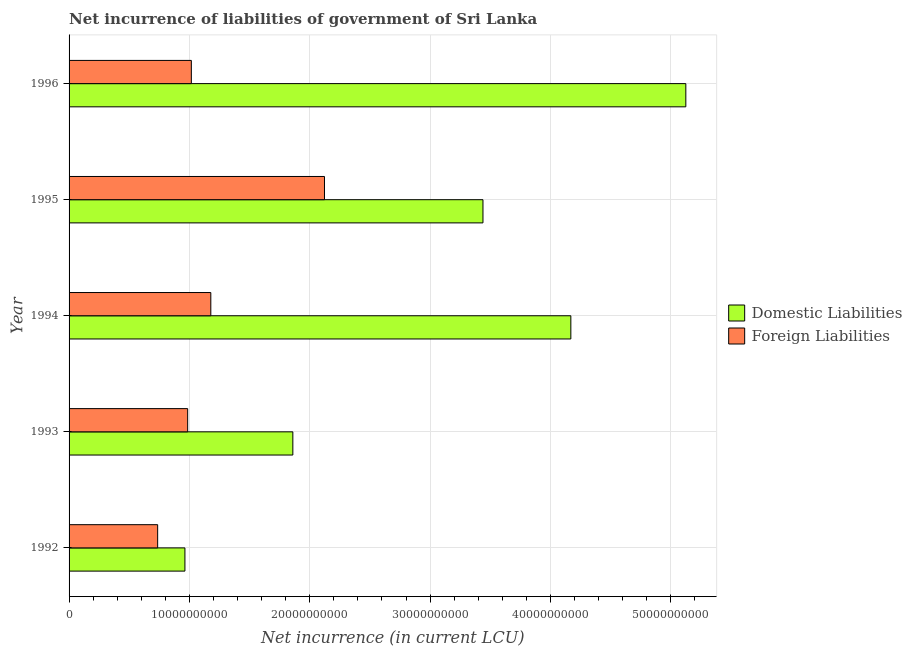Are the number of bars on each tick of the Y-axis equal?
Provide a short and direct response. Yes. How many bars are there on the 2nd tick from the top?
Make the answer very short. 2. How many bars are there on the 3rd tick from the bottom?
Provide a short and direct response. 2. What is the net incurrence of domestic liabilities in 1992?
Keep it short and to the point. 9.63e+09. Across all years, what is the maximum net incurrence of foreign liabilities?
Ensure brevity in your answer.  2.12e+1. Across all years, what is the minimum net incurrence of foreign liabilities?
Your answer should be very brief. 7.36e+09. In which year was the net incurrence of domestic liabilities minimum?
Make the answer very short. 1992. What is the total net incurrence of domestic liabilities in the graph?
Give a very brief answer. 1.56e+11. What is the difference between the net incurrence of foreign liabilities in 1995 and that in 1996?
Offer a terse response. 1.11e+1. What is the difference between the net incurrence of foreign liabilities in 1992 and the net incurrence of domestic liabilities in 1993?
Your answer should be very brief. -1.12e+1. What is the average net incurrence of domestic liabilities per year?
Provide a succinct answer. 3.11e+1. In the year 1996, what is the difference between the net incurrence of domestic liabilities and net incurrence of foreign liabilities?
Keep it short and to the point. 4.11e+1. What is the ratio of the net incurrence of domestic liabilities in 1992 to that in 1993?
Ensure brevity in your answer.  0.52. What is the difference between the highest and the second highest net incurrence of domestic liabilities?
Offer a terse response. 9.56e+09. What is the difference between the highest and the lowest net incurrence of foreign liabilities?
Provide a short and direct response. 1.39e+1. In how many years, is the net incurrence of foreign liabilities greater than the average net incurrence of foreign liabilities taken over all years?
Ensure brevity in your answer.  1. Is the sum of the net incurrence of foreign liabilities in 1992 and 1994 greater than the maximum net incurrence of domestic liabilities across all years?
Keep it short and to the point. No. What does the 2nd bar from the top in 1992 represents?
Offer a very short reply. Domestic Liabilities. What does the 2nd bar from the bottom in 1993 represents?
Your answer should be compact. Foreign Liabilities. How many years are there in the graph?
Provide a succinct answer. 5. How are the legend labels stacked?
Offer a very short reply. Vertical. What is the title of the graph?
Ensure brevity in your answer.  Net incurrence of liabilities of government of Sri Lanka. Does "GDP per capita" appear as one of the legend labels in the graph?
Ensure brevity in your answer.  No. What is the label or title of the X-axis?
Ensure brevity in your answer.  Net incurrence (in current LCU). What is the label or title of the Y-axis?
Make the answer very short. Year. What is the Net incurrence (in current LCU) in Domestic Liabilities in 1992?
Make the answer very short. 9.63e+09. What is the Net incurrence (in current LCU) in Foreign Liabilities in 1992?
Offer a terse response. 7.36e+09. What is the Net incurrence (in current LCU) in Domestic Liabilities in 1993?
Ensure brevity in your answer.  1.86e+1. What is the Net incurrence (in current LCU) of Foreign Liabilities in 1993?
Provide a succinct answer. 9.86e+09. What is the Net incurrence (in current LCU) of Domestic Liabilities in 1994?
Your response must be concise. 4.17e+1. What is the Net incurrence (in current LCU) in Foreign Liabilities in 1994?
Provide a short and direct response. 1.18e+1. What is the Net incurrence (in current LCU) of Domestic Liabilities in 1995?
Give a very brief answer. 3.44e+1. What is the Net incurrence (in current LCU) in Foreign Liabilities in 1995?
Provide a succinct answer. 2.12e+1. What is the Net incurrence (in current LCU) of Domestic Liabilities in 1996?
Keep it short and to the point. 5.12e+1. What is the Net incurrence (in current LCU) of Foreign Liabilities in 1996?
Provide a succinct answer. 1.02e+1. Across all years, what is the maximum Net incurrence (in current LCU) of Domestic Liabilities?
Make the answer very short. 5.12e+1. Across all years, what is the maximum Net incurrence (in current LCU) in Foreign Liabilities?
Ensure brevity in your answer.  2.12e+1. Across all years, what is the minimum Net incurrence (in current LCU) of Domestic Liabilities?
Keep it short and to the point. 9.63e+09. Across all years, what is the minimum Net incurrence (in current LCU) of Foreign Liabilities?
Make the answer very short. 7.36e+09. What is the total Net incurrence (in current LCU) in Domestic Liabilities in the graph?
Ensure brevity in your answer.  1.56e+11. What is the total Net incurrence (in current LCU) of Foreign Liabilities in the graph?
Give a very brief answer. 6.04e+1. What is the difference between the Net incurrence (in current LCU) of Domestic Liabilities in 1992 and that in 1993?
Make the answer very short. -8.97e+09. What is the difference between the Net incurrence (in current LCU) of Foreign Liabilities in 1992 and that in 1993?
Your answer should be very brief. -2.49e+09. What is the difference between the Net incurrence (in current LCU) of Domestic Liabilities in 1992 and that in 1994?
Keep it short and to the point. -3.21e+1. What is the difference between the Net incurrence (in current LCU) in Foreign Liabilities in 1992 and that in 1994?
Keep it short and to the point. -4.42e+09. What is the difference between the Net incurrence (in current LCU) of Domestic Liabilities in 1992 and that in 1995?
Give a very brief answer. -2.48e+1. What is the difference between the Net incurrence (in current LCU) in Foreign Liabilities in 1992 and that in 1995?
Ensure brevity in your answer.  -1.39e+1. What is the difference between the Net incurrence (in current LCU) in Domestic Liabilities in 1992 and that in 1996?
Provide a succinct answer. -4.16e+1. What is the difference between the Net incurrence (in current LCU) in Foreign Liabilities in 1992 and that in 1996?
Your answer should be compact. -2.80e+09. What is the difference between the Net incurrence (in current LCU) in Domestic Liabilities in 1993 and that in 1994?
Make the answer very short. -2.31e+1. What is the difference between the Net incurrence (in current LCU) of Foreign Liabilities in 1993 and that in 1994?
Provide a succinct answer. -1.92e+09. What is the difference between the Net incurrence (in current LCU) in Domestic Liabilities in 1993 and that in 1995?
Offer a terse response. -1.58e+1. What is the difference between the Net incurrence (in current LCU) of Foreign Liabilities in 1993 and that in 1995?
Keep it short and to the point. -1.14e+1. What is the difference between the Net incurrence (in current LCU) of Domestic Liabilities in 1993 and that in 1996?
Offer a very short reply. -3.27e+1. What is the difference between the Net incurrence (in current LCU) of Foreign Liabilities in 1993 and that in 1996?
Give a very brief answer. -3.05e+08. What is the difference between the Net incurrence (in current LCU) in Domestic Liabilities in 1994 and that in 1995?
Your answer should be very brief. 7.30e+09. What is the difference between the Net incurrence (in current LCU) in Foreign Liabilities in 1994 and that in 1995?
Ensure brevity in your answer.  -9.45e+09. What is the difference between the Net incurrence (in current LCU) of Domestic Liabilities in 1994 and that in 1996?
Keep it short and to the point. -9.56e+09. What is the difference between the Net incurrence (in current LCU) in Foreign Liabilities in 1994 and that in 1996?
Give a very brief answer. 1.62e+09. What is the difference between the Net incurrence (in current LCU) in Domestic Liabilities in 1995 and that in 1996?
Keep it short and to the point. -1.69e+1. What is the difference between the Net incurrence (in current LCU) of Foreign Liabilities in 1995 and that in 1996?
Your response must be concise. 1.11e+1. What is the difference between the Net incurrence (in current LCU) of Domestic Liabilities in 1992 and the Net incurrence (in current LCU) of Foreign Liabilities in 1993?
Provide a short and direct response. -2.28e+08. What is the difference between the Net incurrence (in current LCU) of Domestic Liabilities in 1992 and the Net incurrence (in current LCU) of Foreign Liabilities in 1994?
Offer a very short reply. -2.15e+09. What is the difference between the Net incurrence (in current LCU) in Domestic Liabilities in 1992 and the Net incurrence (in current LCU) in Foreign Liabilities in 1995?
Ensure brevity in your answer.  -1.16e+1. What is the difference between the Net incurrence (in current LCU) in Domestic Liabilities in 1992 and the Net incurrence (in current LCU) in Foreign Liabilities in 1996?
Ensure brevity in your answer.  -5.33e+08. What is the difference between the Net incurrence (in current LCU) in Domestic Liabilities in 1993 and the Net incurrence (in current LCU) in Foreign Liabilities in 1994?
Give a very brief answer. 6.82e+09. What is the difference between the Net incurrence (in current LCU) of Domestic Liabilities in 1993 and the Net incurrence (in current LCU) of Foreign Liabilities in 1995?
Ensure brevity in your answer.  -2.63e+09. What is the difference between the Net incurrence (in current LCU) of Domestic Liabilities in 1993 and the Net incurrence (in current LCU) of Foreign Liabilities in 1996?
Keep it short and to the point. 8.43e+09. What is the difference between the Net incurrence (in current LCU) in Domestic Liabilities in 1994 and the Net incurrence (in current LCU) in Foreign Liabilities in 1995?
Make the answer very short. 2.05e+1. What is the difference between the Net incurrence (in current LCU) of Domestic Liabilities in 1994 and the Net incurrence (in current LCU) of Foreign Liabilities in 1996?
Provide a short and direct response. 3.15e+1. What is the difference between the Net incurrence (in current LCU) in Domestic Liabilities in 1995 and the Net incurrence (in current LCU) in Foreign Liabilities in 1996?
Your answer should be compact. 2.42e+1. What is the average Net incurrence (in current LCU) in Domestic Liabilities per year?
Ensure brevity in your answer.  3.11e+1. What is the average Net incurrence (in current LCU) of Foreign Liabilities per year?
Offer a very short reply. 1.21e+1. In the year 1992, what is the difference between the Net incurrence (in current LCU) in Domestic Liabilities and Net incurrence (in current LCU) in Foreign Liabilities?
Offer a terse response. 2.27e+09. In the year 1993, what is the difference between the Net incurrence (in current LCU) in Domestic Liabilities and Net incurrence (in current LCU) in Foreign Liabilities?
Provide a short and direct response. 8.74e+09. In the year 1994, what is the difference between the Net incurrence (in current LCU) in Domestic Liabilities and Net incurrence (in current LCU) in Foreign Liabilities?
Your response must be concise. 2.99e+1. In the year 1995, what is the difference between the Net incurrence (in current LCU) in Domestic Liabilities and Net incurrence (in current LCU) in Foreign Liabilities?
Your answer should be compact. 1.32e+1. In the year 1996, what is the difference between the Net incurrence (in current LCU) of Domestic Liabilities and Net incurrence (in current LCU) of Foreign Liabilities?
Ensure brevity in your answer.  4.11e+1. What is the ratio of the Net incurrence (in current LCU) in Domestic Liabilities in 1992 to that in 1993?
Offer a very short reply. 0.52. What is the ratio of the Net incurrence (in current LCU) in Foreign Liabilities in 1992 to that in 1993?
Make the answer very short. 0.75. What is the ratio of the Net incurrence (in current LCU) of Domestic Liabilities in 1992 to that in 1994?
Provide a succinct answer. 0.23. What is the ratio of the Net incurrence (in current LCU) of Domestic Liabilities in 1992 to that in 1995?
Your answer should be very brief. 0.28. What is the ratio of the Net incurrence (in current LCU) in Foreign Liabilities in 1992 to that in 1995?
Give a very brief answer. 0.35. What is the ratio of the Net incurrence (in current LCU) of Domestic Liabilities in 1992 to that in 1996?
Offer a very short reply. 0.19. What is the ratio of the Net incurrence (in current LCU) in Foreign Liabilities in 1992 to that in 1996?
Your response must be concise. 0.72. What is the ratio of the Net incurrence (in current LCU) of Domestic Liabilities in 1993 to that in 1994?
Give a very brief answer. 0.45. What is the ratio of the Net incurrence (in current LCU) in Foreign Liabilities in 1993 to that in 1994?
Give a very brief answer. 0.84. What is the ratio of the Net incurrence (in current LCU) in Domestic Liabilities in 1993 to that in 1995?
Your response must be concise. 0.54. What is the ratio of the Net incurrence (in current LCU) in Foreign Liabilities in 1993 to that in 1995?
Provide a succinct answer. 0.46. What is the ratio of the Net incurrence (in current LCU) in Domestic Liabilities in 1993 to that in 1996?
Make the answer very short. 0.36. What is the ratio of the Net incurrence (in current LCU) in Foreign Liabilities in 1993 to that in 1996?
Offer a terse response. 0.97. What is the ratio of the Net incurrence (in current LCU) of Domestic Liabilities in 1994 to that in 1995?
Your response must be concise. 1.21. What is the ratio of the Net incurrence (in current LCU) in Foreign Liabilities in 1994 to that in 1995?
Your answer should be very brief. 0.55. What is the ratio of the Net incurrence (in current LCU) in Domestic Liabilities in 1994 to that in 1996?
Your answer should be compact. 0.81. What is the ratio of the Net incurrence (in current LCU) in Foreign Liabilities in 1994 to that in 1996?
Your response must be concise. 1.16. What is the ratio of the Net incurrence (in current LCU) in Domestic Liabilities in 1995 to that in 1996?
Make the answer very short. 0.67. What is the ratio of the Net incurrence (in current LCU) of Foreign Liabilities in 1995 to that in 1996?
Provide a succinct answer. 2.09. What is the difference between the highest and the second highest Net incurrence (in current LCU) in Domestic Liabilities?
Offer a very short reply. 9.56e+09. What is the difference between the highest and the second highest Net incurrence (in current LCU) of Foreign Liabilities?
Keep it short and to the point. 9.45e+09. What is the difference between the highest and the lowest Net incurrence (in current LCU) in Domestic Liabilities?
Ensure brevity in your answer.  4.16e+1. What is the difference between the highest and the lowest Net incurrence (in current LCU) of Foreign Liabilities?
Your response must be concise. 1.39e+1. 